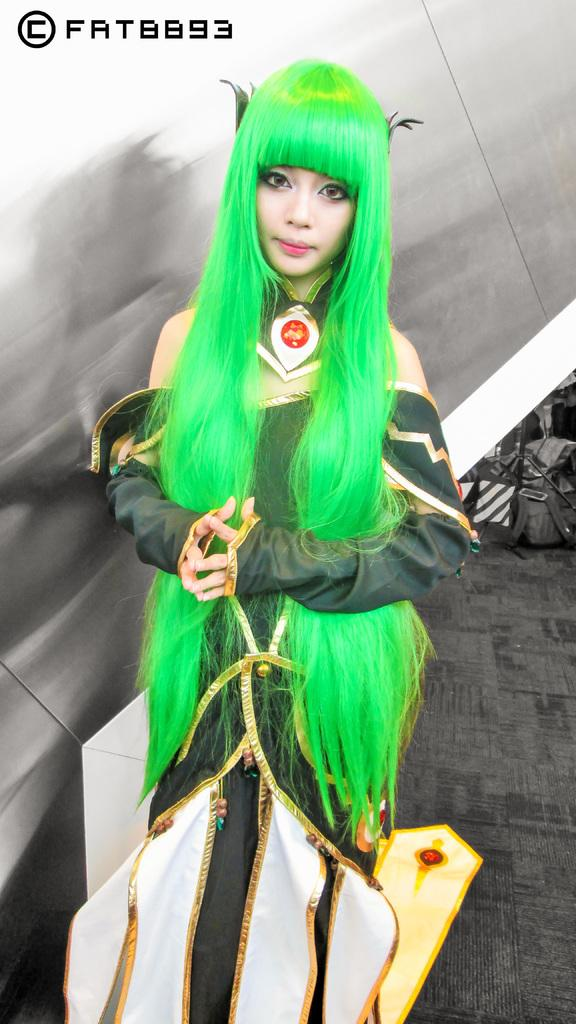Who or what is present in the image? There is a person in the image. What is the person wearing? The person is wearing clothes. What can be seen on the right side of the image? There is a bag on the right side of the image. Where is the text located in the image? The text is in the top left of the image. How many crates are stacked on top of each other in the image? There are no crates present in the image. 